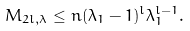Convert formula to latex. <formula><loc_0><loc_0><loc_500><loc_500>M _ { 2 l , \lambda } \leq n ( \lambda _ { 1 } - 1 ) ^ { l } \lambda _ { 1 } ^ { l - 1 } .</formula> 